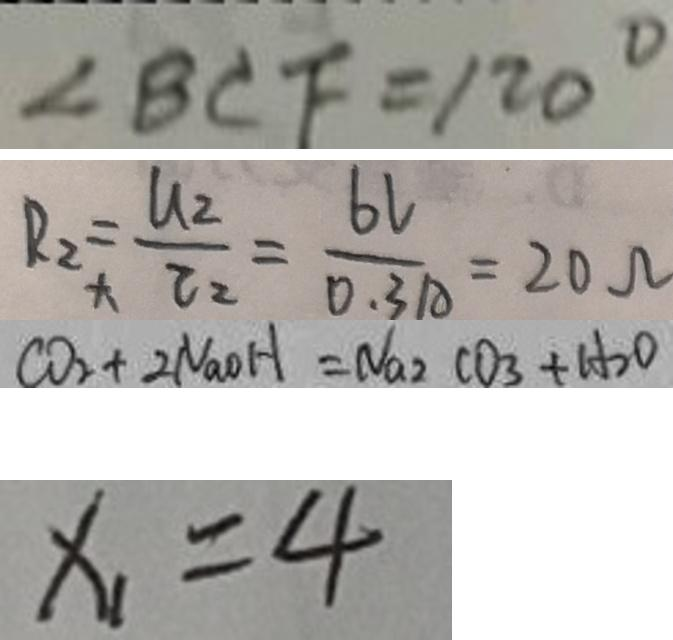<formula> <loc_0><loc_0><loc_500><loc_500>\angle B C F = 1 2 0 ^ { \circ } 
 R _ { 2 } = \frac { d _ { 2 } } { l _ { 2 } } = \frac { 6 l } { 0 . 3 1 A } = 2 0 \Omega 
 C O _ { 2 } + 2 N a O H = N a _ { 2 } C O _ { 3 } + H _ { 2 } O 
 x _ { 1 } = 4</formula> 